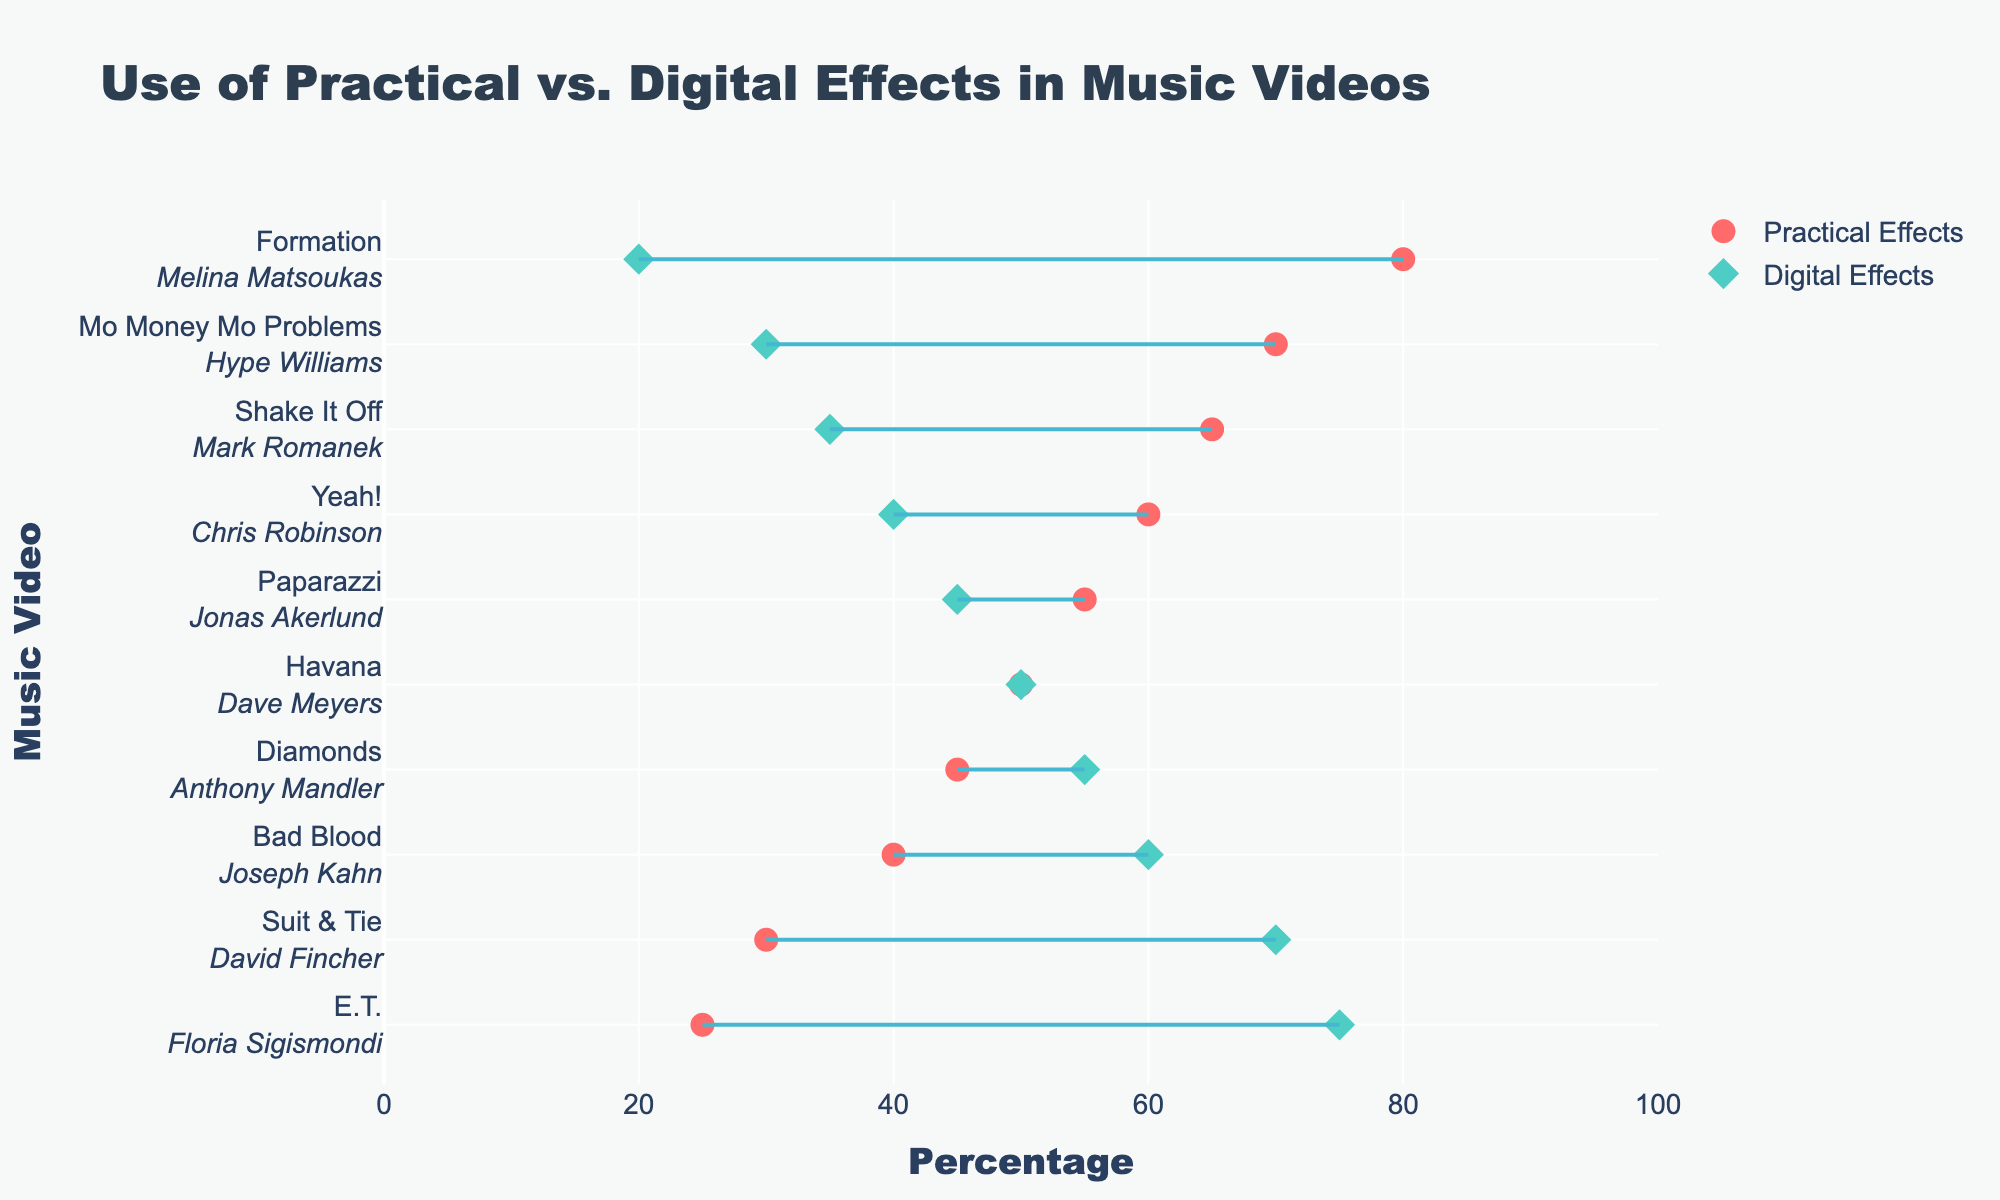What is the title of the plot? The title can be found at the top of the plot. The title is "Use of Practical vs. Digital Effects in Music Videos".
Answer: Use of Practical vs. Digital Effects in Music Videos How many music videos are represented in the plot? Each line represents a different music video. Counting these lines, we determine there are 10 music videos.
Answer: 10 Which music video uses the highest percentage of practical effects? The music video with the highest percentage of practical effects is at the top when sorted by the difference in effects. "Formation" by Melina Matsoukas uses 80% practical effects, which is the highest.
Answer: Formation Which video relies more on digital effects than any other? The music video with the highest percentage of digital effects can be found at the bottom if sorted by digital effects. "E.T." by Floria Sigismondi uses 75% digital effects, the highest among all videos.
Answer: E.T What is the average use of digital effects across all the music videos? To find this, add the percentages of digital effects and then divide by the number of videos: (60 + 30 + 45 + 50 + 20 + 40 + 70 + 55 + 75 + 35) / 10 = 48%.
Answer: 48% Compare "Bad Blood" and "Suit & Tie"; which uses a higher percentage of practical effects? By looking at the markers at the respective positions for "Bad Blood" and "Suit & Tie", we see that "Bad Blood" uses 40% practical effects while "Suit & Tie" uses 30%. Therefore, "Bad Blood" has a higher percentage.
Answer: Bad Blood Which two videos have an even split between practical and digital effects? Both markers for practical and digital effects for a video should be at the 50% mark to be even. "Havana" by Dave Meyers shows a 50-50 split.
Answer: Havana In "Mo Money Mo Problems," what is the percentage difference between practical and digital effects? We need to subtract the percentage of digital effects from practical effects in "Mo Money Mo Problems" (70 - 30 = 40%).
Answer: 40% Which director has the closest balance between practical and digital effects in their video? This involves checking for the smallest difference between the two percentages. "Havana" has a 50-50 balance making it the closest to balance.
Answer: Dave Meyers For the music video "Diamonds," how much more are digital effects used compared to practical effects? The digital effects percentage minus the practical effects percentage for "Diamonds" gives us the difference (55 - 45 = 10%).
Answer: 10% 